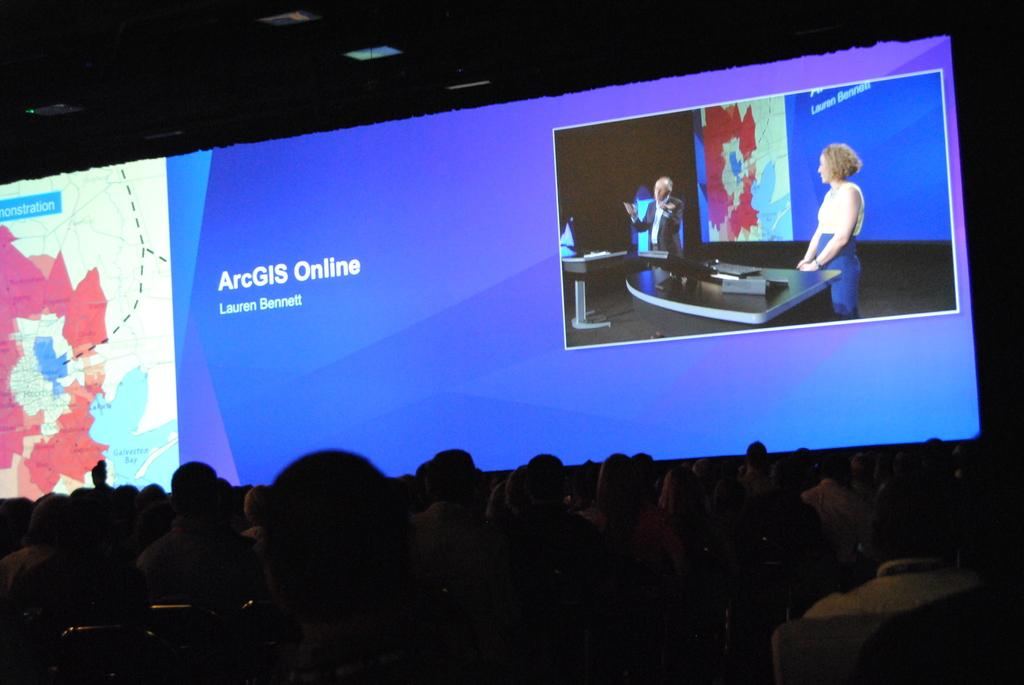<image>
Relay a brief, clear account of the picture shown. A crowd is watching a presentation and a large projector screen says ArcGIS Online Lauren Bennett. 